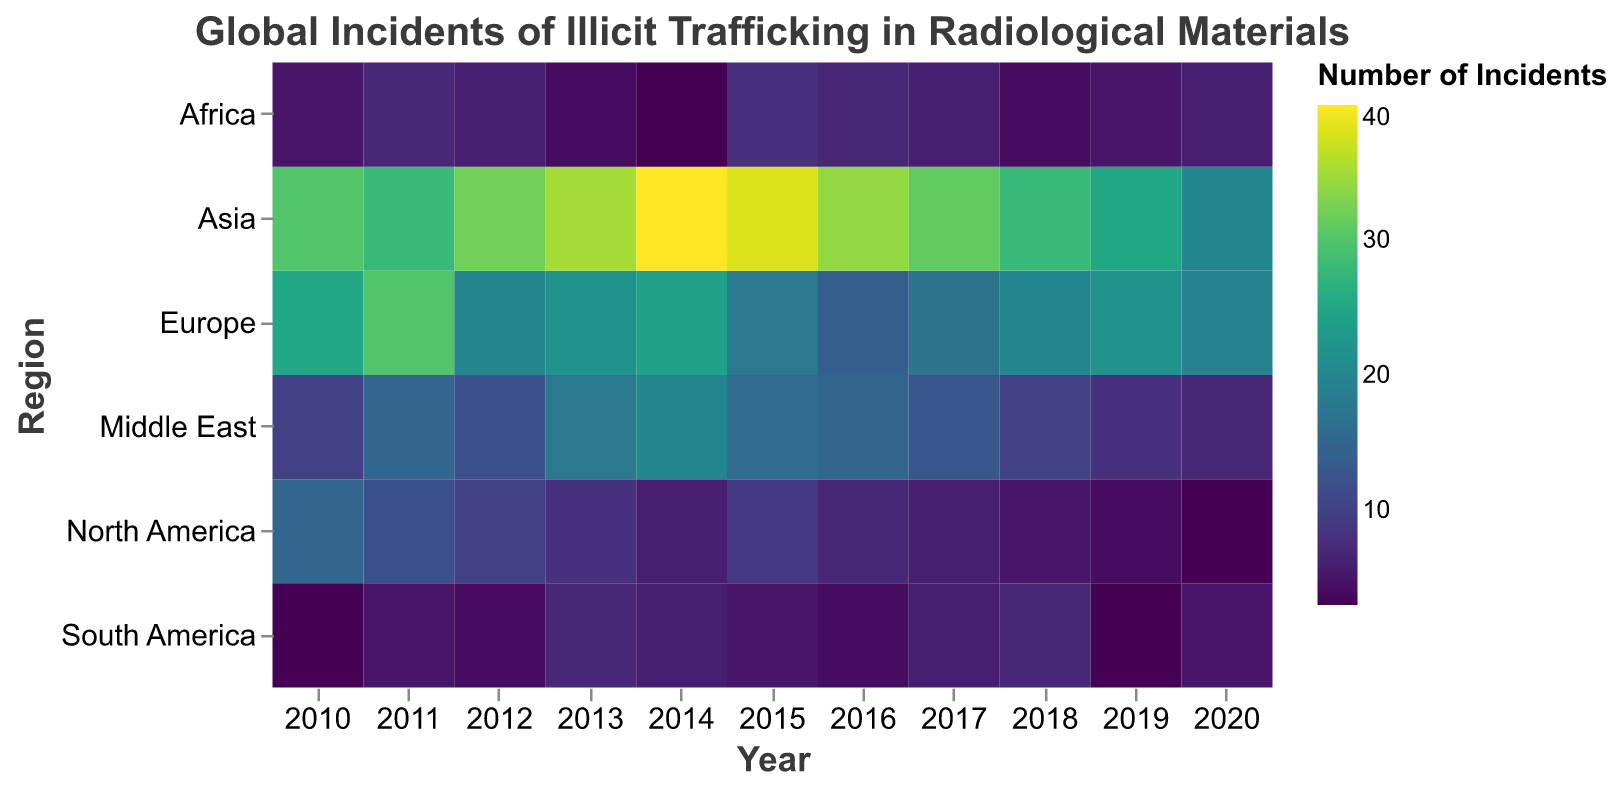What is the title of the heatmap? The title of the heatmap is displayed at the top center of the figure. It reads "Global Incidents of Illicit Trafficking in Radiological Materials". This is derived from the title specification in the code block.
Answer: Global Incidents of Illicit Trafficking in Radiological Materials Which year had the highest number of incidents in Asia? By examining the heatmap, look for the darkest color in the row corresponding to Asia. The darkest cell in the Asia row corresponds to the year 2014 with 40 incidents.
Answer: 2014 What are the regions shown on the y-axis? The regions on the y-axis are displayed vertically on the heatmap; they are North America, Europe, Asia, Middle East, Africa, and South America.
Answer: North America, Europe, Asia, Middle East, Africa, South America In which year did North America have the lowest number of incidents? To find the year of the lowest number of incidents for North America, look for the lightest cell in the North America row. The lightest cell corresponds to the year 2020 with 3 incidents.
Answer: 2020 Compare the number of incidents in Europe for the years 2011 and 2015. Which year had more incidents? By examining the heatmap, notice the color intensity in the Europe row for 2011 and 2015. The cell for 2011 is darker with 30 incidents compared to 18 incidents in 2015.
Answer: 2011 What is the overall trend in the number of incidents in Asia from 2010 to 2020? Examine the color intensity from left to right in the Asia row. The color intensifies (indicating more incidents) up to 2014, then decreases towards 2020, suggesting an overall decline after a peak.
Answer: Increasing until 2014, then decreasing Which region had the highest number of incidents in any single year? By identifying the darkest cell in the entire heatmap, we find it in the Asia row for 2014, representing 40 incidents.
Answer: Asia Calculate the combined number of incidents in Africa for the years 2018 and 2020. By adding the number of incidents in Africa for 2018 (4) and 2020 (6), the total number of incidents is 10.
Answer: 10 Identify the year in which the Middle East had the most significant increase in incidents compared to the previous year. Calculate the difference in incidents year-over-year for the Middle East, the largest increase is from 2012 (12 incidents) to 2013 (18 incidents), with a difference of 6.
Answer: 2013 How does the number of incidents in Europe generally change over the years? By following the Europe row from 2010 to 2020, we observe fluctuations but an overall slight decrease in color intensity, indicating a general decline in incidents.
Answer: Generally decreasing 